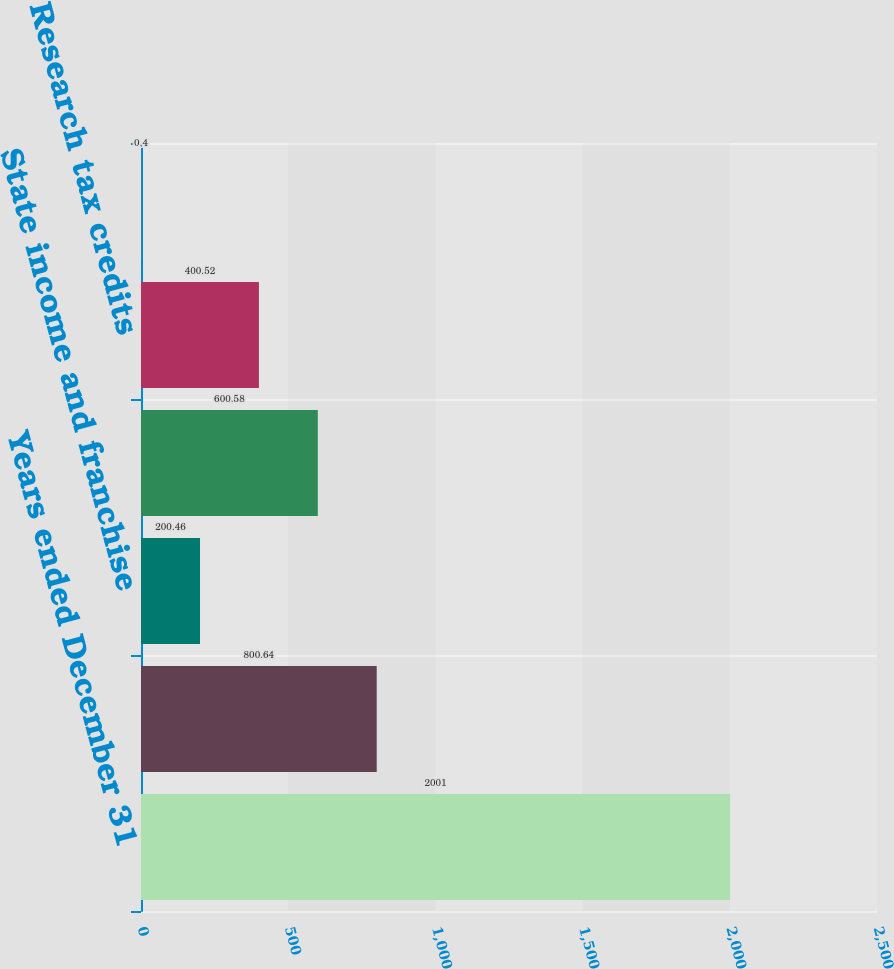Convert chart to OTSL. <chart><loc_0><loc_0><loc_500><loc_500><bar_chart><fcel>Years ended December 31<fcel>Provision at US federal<fcel>State income and franchise<fcel>International income tax rate<fcel>Research tax credits<fcel>Other<nl><fcel>2001<fcel>800.64<fcel>200.46<fcel>600.58<fcel>400.52<fcel>0.4<nl></chart> 